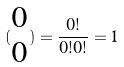<formula> <loc_0><loc_0><loc_500><loc_500>( \begin{matrix} 0 \\ 0 \end{matrix} ) = \frac { 0 ! } { 0 ! 0 ! } = 1</formula> 